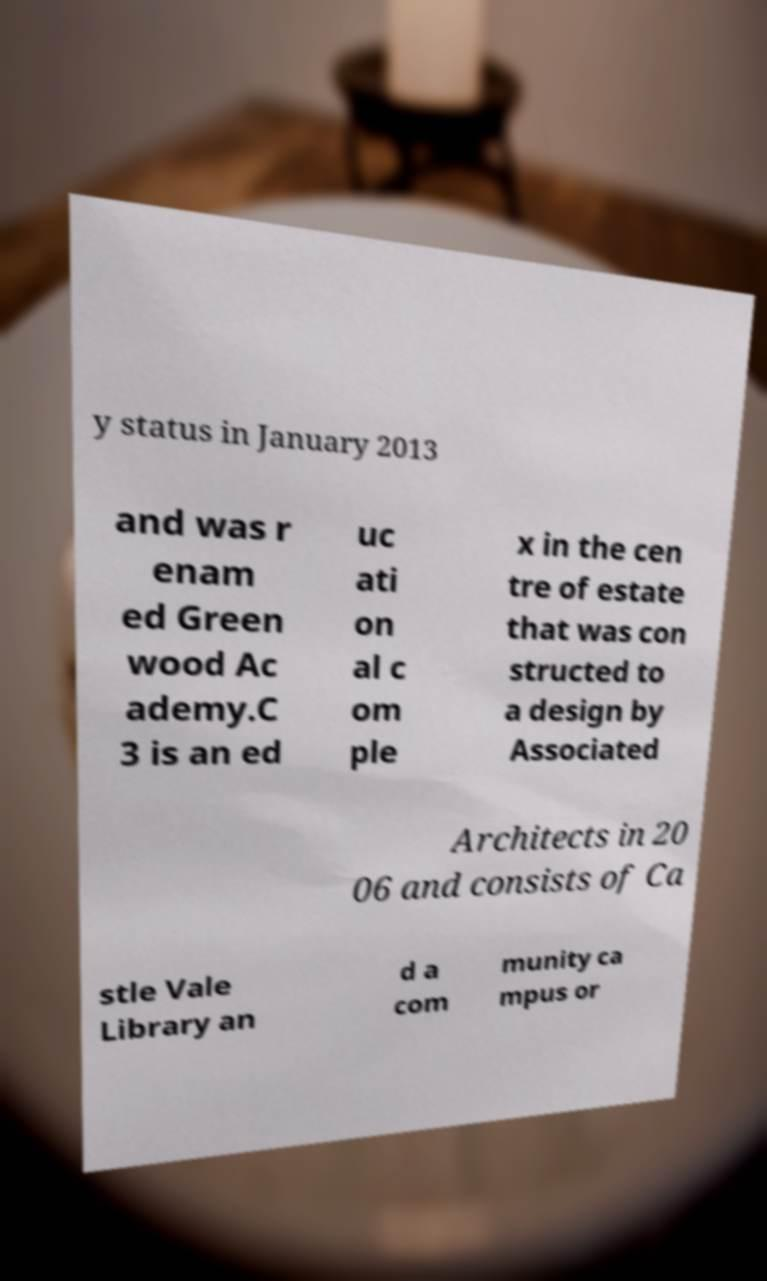Please identify and transcribe the text found in this image. y status in January 2013 and was r enam ed Green wood Ac ademy.C 3 is an ed uc ati on al c om ple x in the cen tre of estate that was con structed to a design by Associated Architects in 20 06 and consists of Ca stle Vale Library an d a com munity ca mpus or 